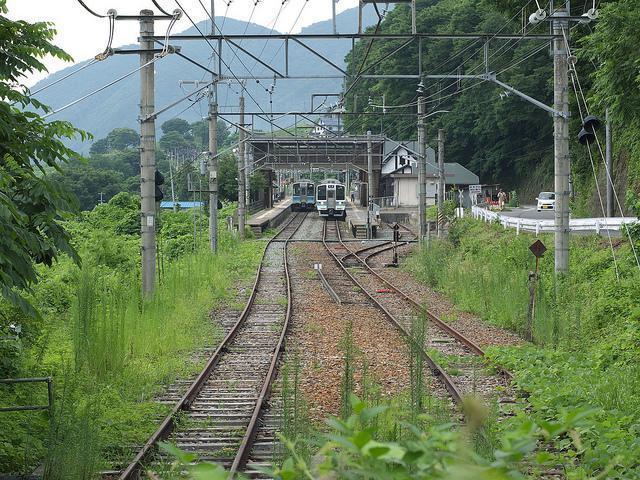How many trains can be seen?
Give a very brief answer. 2. 